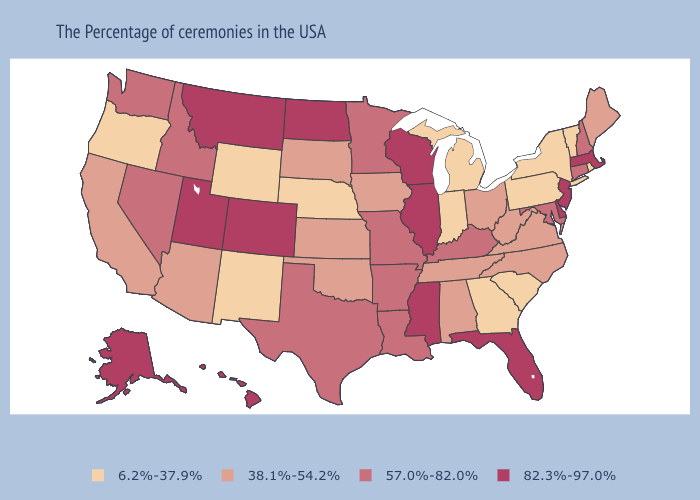Which states have the lowest value in the USA?
Quick response, please. Rhode Island, Vermont, New York, Pennsylvania, South Carolina, Georgia, Michigan, Indiana, Nebraska, Wyoming, New Mexico, Oregon. Does Wyoming have the highest value in the USA?
Write a very short answer. No. Does the map have missing data?
Concise answer only. No. What is the value of Michigan?
Keep it brief. 6.2%-37.9%. Does the first symbol in the legend represent the smallest category?
Concise answer only. Yes. Among the states that border Missouri , does Nebraska have the lowest value?
Give a very brief answer. Yes. What is the value of Utah?
Keep it brief. 82.3%-97.0%. Name the states that have a value in the range 38.1%-54.2%?
Keep it brief. Maine, Virginia, North Carolina, West Virginia, Ohio, Alabama, Tennessee, Iowa, Kansas, Oklahoma, South Dakota, Arizona, California. Name the states that have a value in the range 38.1%-54.2%?
Write a very short answer. Maine, Virginia, North Carolina, West Virginia, Ohio, Alabama, Tennessee, Iowa, Kansas, Oklahoma, South Dakota, Arizona, California. Does the first symbol in the legend represent the smallest category?
Be succinct. Yes. Which states have the lowest value in the USA?
Short answer required. Rhode Island, Vermont, New York, Pennsylvania, South Carolina, Georgia, Michigan, Indiana, Nebraska, Wyoming, New Mexico, Oregon. Does Arizona have the same value as West Virginia?
Write a very short answer. Yes. Name the states that have a value in the range 6.2%-37.9%?
Short answer required. Rhode Island, Vermont, New York, Pennsylvania, South Carolina, Georgia, Michigan, Indiana, Nebraska, Wyoming, New Mexico, Oregon. What is the value of Utah?
Write a very short answer. 82.3%-97.0%. What is the highest value in states that border Iowa?
Answer briefly. 82.3%-97.0%. 